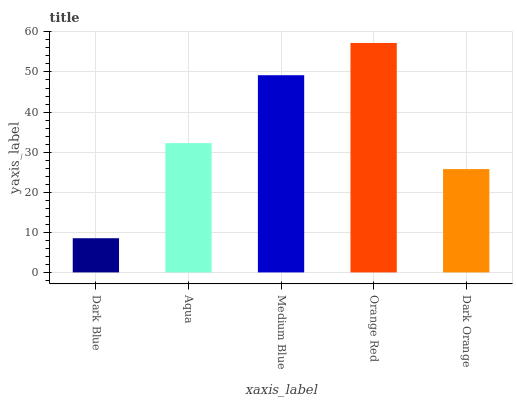Is Dark Blue the minimum?
Answer yes or no. Yes. Is Orange Red the maximum?
Answer yes or no. Yes. Is Aqua the minimum?
Answer yes or no. No. Is Aqua the maximum?
Answer yes or no. No. Is Aqua greater than Dark Blue?
Answer yes or no. Yes. Is Dark Blue less than Aqua?
Answer yes or no. Yes. Is Dark Blue greater than Aqua?
Answer yes or no. No. Is Aqua less than Dark Blue?
Answer yes or no. No. Is Aqua the high median?
Answer yes or no. Yes. Is Aqua the low median?
Answer yes or no. Yes. Is Dark Blue the high median?
Answer yes or no. No. Is Orange Red the low median?
Answer yes or no. No. 